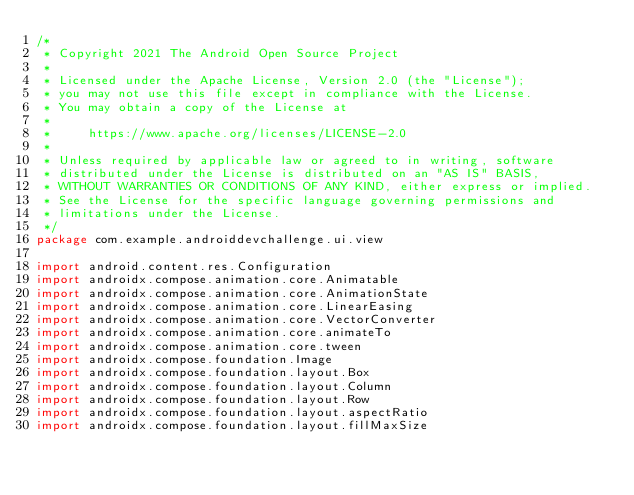<code> <loc_0><loc_0><loc_500><loc_500><_Kotlin_>/*
 * Copyright 2021 The Android Open Source Project
 *
 * Licensed under the Apache License, Version 2.0 (the "License");
 * you may not use this file except in compliance with the License.
 * You may obtain a copy of the License at
 *
 *     https://www.apache.org/licenses/LICENSE-2.0
 *
 * Unless required by applicable law or agreed to in writing, software
 * distributed under the License is distributed on an "AS IS" BASIS,
 * WITHOUT WARRANTIES OR CONDITIONS OF ANY KIND, either express or implied.
 * See the License for the specific language governing permissions and
 * limitations under the License.
 */
package com.example.androiddevchallenge.ui.view

import android.content.res.Configuration
import androidx.compose.animation.core.Animatable
import androidx.compose.animation.core.AnimationState
import androidx.compose.animation.core.LinearEasing
import androidx.compose.animation.core.VectorConverter
import androidx.compose.animation.core.animateTo
import androidx.compose.animation.core.tween
import androidx.compose.foundation.Image
import androidx.compose.foundation.layout.Box
import androidx.compose.foundation.layout.Column
import androidx.compose.foundation.layout.Row
import androidx.compose.foundation.layout.aspectRatio
import androidx.compose.foundation.layout.fillMaxSize</code> 